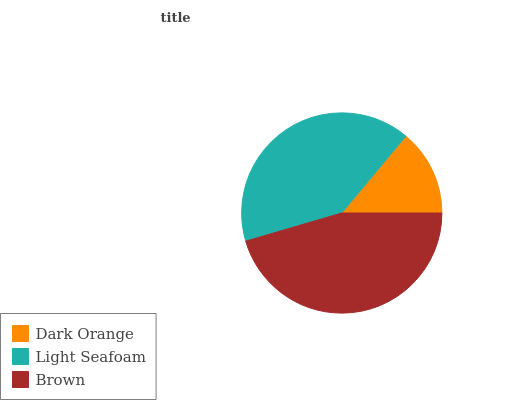Is Dark Orange the minimum?
Answer yes or no. Yes. Is Brown the maximum?
Answer yes or no. Yes. Is Light Seafoam the minimum?
Answer yes or no. No. Is Light Seafoam the maximum?
Answer yes or no. No. Is Light Seafoam greater than Dark Orange?
Answer yes or no. Yes. Is Dark Orange less than Light Seafoam?
Answer yes or no. Yes. Is Dark Orange greater than Light Seafoam?
Answer yes or no. No. Is Light Seafoam less than Dark Orange?
Answer yes or no. No. Is Light Seafoam the high median?
Answer yes or no. Yes. Is Light Seafoam the low median?
Answer yes or no. Yes. Is Brown the high median?
Answer yes or no. No. Is Brown the low median?
Answer yes or no. No. 